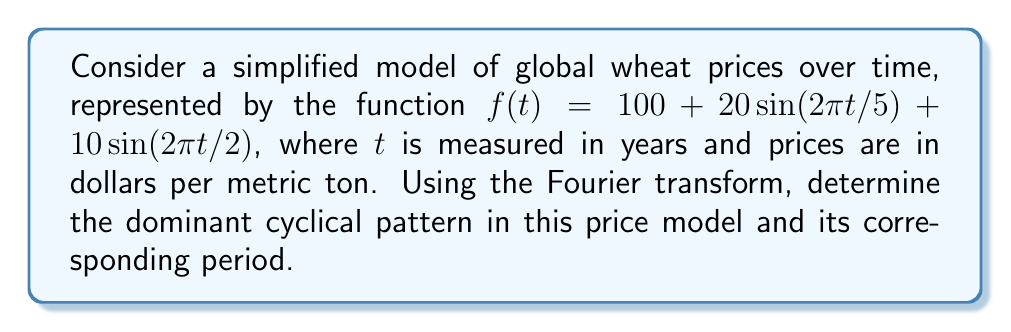Provide a solution to this math problem. To analyze the cyclical patterns in the given price function, we'll use the Fourier transform. The steps are as follows:

1) The Fourier transform of $f(t)$ is given by:

   $$F(\omega) = \int_{-\infty}^{\infty} f(t)e^{-i\omega t}dt$$

2) In our case, $f(t) = 100 + 20\sin(2\pi t/5) + 10\sin(2\pi t/2)$

3) The constant term 100 will result in a delta function at $\omega = 0$ in the frequency domain, which we can ignore for cyclical analysis.

4) For the sinusoidal terms, we can use the Fourier transform property:

   $$\mathcal{F}\{A\sin(at)\} = \frac{A}{2i}[\delta(\omega - a) - \delta(\omega + a)]$$

5) Applying this to our function:

   $$F(\omega) = 10\pi[\delta(\omega - 2\pi/5) - \delta(\omega + 2\pi/5)] + 5\pi[\delta(\omega - \pi) - \delta(\omega + \pi)]$$

6) The magnitude of the Fourier transform will have peaks at $\omega = 2\pi/5$ and $\omega = \pi$, corresponding to the frequencies in the original function.

7) The dominant cyclical pattern will be the one with the larger coefficient, which is $20\sin(2\pi t/5)$.

8) The period of this dominant cycle is $T = 2\pi/\omega = 2\pi/(2\pi/5) = 5$ years.
Answer: 5 years 